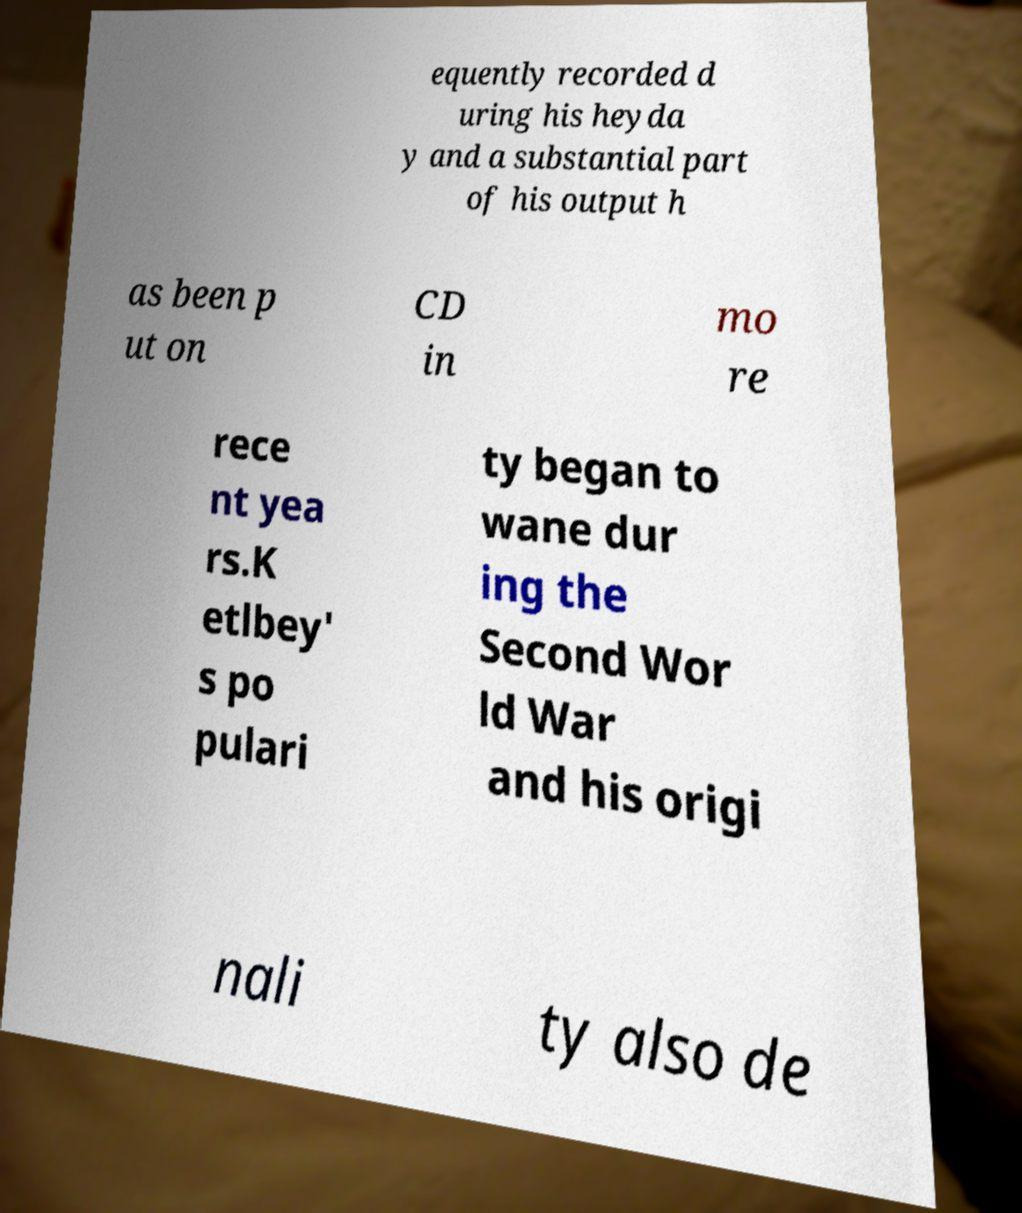Can you accurately transcribe the text from the provided image for me? equently recorded d uring his heyda y and a substantial part of his output h as been p ut on CD in mo re rece nt yea rs.K etlbey' s po pulari ty began to wane dur ing the Second Wor ld War and his origi nali ty also de 